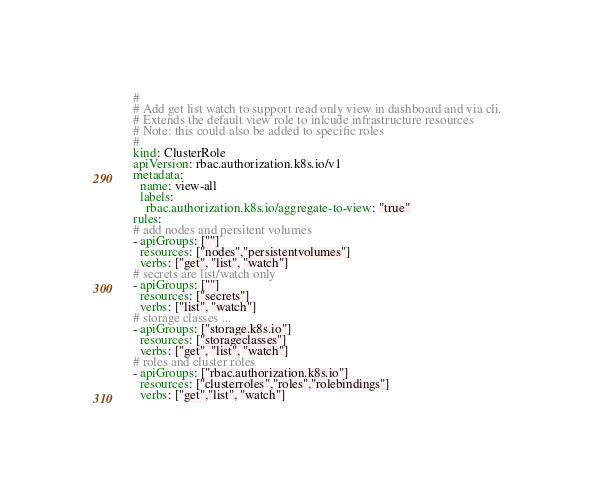Convert code to text. <code><loc_0><loc_0><loc_500><loc_500><_YAML_>#
# Add get list watch to support read only view in dashboard and via cli.
# Extends the default view role to inlcude infrastructure resources
# Note: this could also be added to specific roles
#
kind: ClusterRole
apiVersion: rbac.authorization.k8s.io/v1
metadata:
  name: view-all
  labels:
    rbac.authorization.k8s.io/aggregate-to-view: "true"
rules:
# add nodes and persitent volumes
- apiGroups: [""]
  resources: ["nodes","persistentvolumes"]
  verbs: ["get", "list", "watch"]
# secrets are list/watch only
- apiGroups: [""]
  resources: ["secrets"]
  verbs: ["list", "watch"]
# storage classes ...  
- apiGroups: ["storage.k8s.io"]
  resources: ["storageclasses"]
  verbs: ["get", "list", "watch"]
# roles and cluster roles 
- apiGroups: ["rbac.authorization.k8s.io"]
  resources: ["clusterroles","roles","rolebindings"]
  verbs: ["get","list", "watch"]</code> 